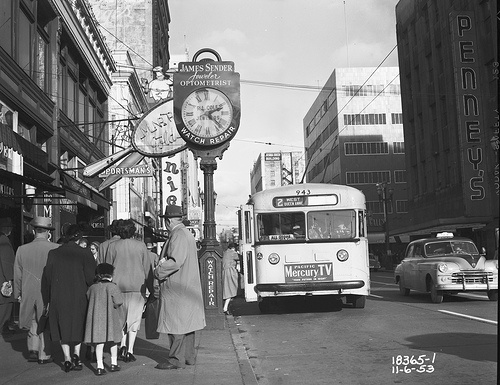Describe the objects in this image and their specific colors. I can see bus in gray, lightgray, darkgray, and black tones, people in gray, darkgray, black, and lightgray tones, car in gray, black, lightgray, and darkgray tones, people in gray, black, darkgray, and lightgray tones, and people in gray, darkgray, black, and lightgray tones in this image. 